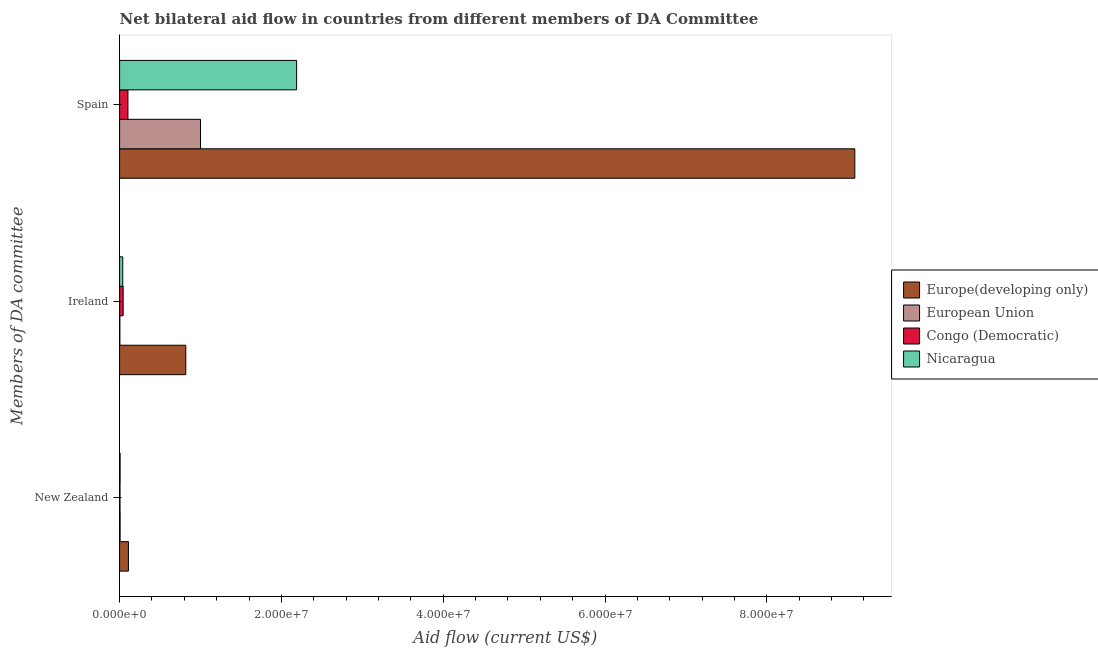How many groups of bars are there?
Your answer should be compact. 3. Are the number of bars per tick equal to the number of legend labels?
Keep it short and to the point. Yes. What is the label of the 2nd group of bars from the top?
Your answer should be compact. Ireland. What is the amount of aid provided by ireland in Nicaragua?
Your answer should be very brief. 3.90e+05. Across all countries, what is the maximum amount of aid provided by new zealand?
Keep it short and to the point. 1.09e+06. Across all countries, what is the minimum amount of aid provided by new zealand?
Your answer should be very brief. 5.00e+04. In which country was the amount of aid provided by spain maximum?
Your answer should be compact. Europe(developing only). In which country was the amount of aid provided by spain minimum?
Keep it short and to the point. Congo (Democratic). What is the total amount of aid provided by new zealand in the graph?
Provide a short and direct response. 1.26e+06. What is the difference between the amount of aid provided by ireland in Europe(developing only) and that in European Union?
Provide a succinct answer. 8.15e+06. What is the difference between the amount of aid provided by spain in Europe(developing only) and the amount of aid provided by ireland in Congo (Democratic)?
Provide a succinct answer. 9.04e+07. What is the average amount of aid provided by spain per country?
Your answer should be compact. 3.09e+07. What is the difference between the amount of aid provided by ireland and amount of aid provided by new zealand in Nicaragua?
Your response must be concise. 3.30e+05. In how many countries, is the amount of aid provided by ireland greater than 24000000 US$?
Provide a short and direct response. 0. Is the amount of aid provided by ireland in Europe(developing only) less than that in European Union?
Provide a succinct answer. No. Is the difference between the amount of aid provided by new zealand in Congo (Democratic) and European Union greater than the difference between the amount of aid provided by spain in Congo (Democratic) and European Union?
Ensure brevity in your answer.  Yes. What is the difference between the highest and the second highest amount of aid provided by spain?
Your answer should be compact. 6.90e+07. What is the difference between the highest and the lowest amount of aid provided by new zealand?
Your answer should be compact. 1.04e+06. In how many countries, is the amount of aid provided by ireland greater than the average amount of aid provided by ireland taken over all countries?
Keep it short and to the point. 1. Is the sum of the amount of aid provided by ireland in Nicaragua and Congo (Democratic) greater than the maximum amount of aid provided by spain across all countries?
Offer a terse response. No. What does the 1st bar from the top in New Zealand represents?
Make the answer very short. Nicaragua. What does the 3rd bar from the bottom in Spain represents?
Offer a very short reply. Congo (Democratic). How many countries are there in the graph?
Your answer should be compact. 4. What is the difference between two consecutive major ticks on the X-axis?
Provide a short and direct response. 2.00e+07. Does the graph contain grids?
Your answer should be compact. No. Where does the legend appear in the graph?
Provide a short and direct response. Center right. How many legend labels are there?
Provide a short and direct response. 4. How are the legend labels stacked?
Give a very brief answer. Vertical. What is the title of the graph?
Provide a short and direct response. Net bilateral aid flow in countries from different members of DA Committee. Does "Paraguay" appear as one of the legend labels in the graph?
Offer a very short reply. No. What is the label or title of the Y-axis?
Your answer should be compact. Members of DA committee. What is the Aid flow (current US$) in Europe(developing only) in New Zealand?
Your answer should be compact. 1.09e+06. What is the Aid flow (current US$) of European Union in New Zealand?
Provide a succinct answer. 6.00e+04. What is the Aid flow (current US$) in Nicaragua in New Zealand?
Offer a very short reply. 6.00e+04. What is the Aid flow (current US$) of Europe(developing only) in Ireland?
Offer a terse response. 8.18e+06. What is the Aid flow (current US$) of European Union in Ireland?
Offer a very short reply. 3.00e+04. What is the Aid flow (current US$) of Europe(developing only) in Spain?
Ensure brevity in your answer.  9.09e+07. What is the Aid flow (current US$) of Congo (Democratic) in Spain?
Your response must be concise. 1.03e+06. What is the Aid flow (current US$) in Nicaragua in Spain?
Your answer should be very brief. 2.19e+07. Across all Members of DA committee, what is the maximum Aid flow (current US$) of Europe(developing only)?
Your answer should be very brief. 9.09e+07. Across all Members of DA committee, what is the maximum Aid flow (current US$) in European Union?
Give a very brief answer. 1.00e+07. Across all Members of DA committee, what is the maximum Aid flow (current US$) in Congo (Democratic)?
Your response must be concise. 1.03e+06. Across all Members of DA committee, what is the maximum Aid flow (current US$) in Nicaragua?
Make the answer very short. 2.19e+07. Across all Members of DA committee, what is the minimum Aid flow (current US$) of Europe(developing only)?
Ensure brevity in your answer.  1.09e+06. Across all Members of DA committee, what is the minimum Aid flow (current US$) of Congo (Democratic)?
Ensure brevity in your answer.  5.00e+04. What is the total Aid flow (current US$) of Europe(developing only) in the graph?
Keep it short and to the point. 1.00e+08. What is the total Aid flow (current US$) of European Union in the graph?
Offer a very short reply. 1.01e+07. What is the total Aid flow (current US$) in Congo (Democratic) in the graph?
Keep it short and to the point. 1.52e+06. What is the total Aid flow (current US$) of Nicaragua in the graph?
Your answer should be very brief. 2.23e+07. What is the difference between the Aid flow (current US$) in Europe(developing only) in New Zealand and that in Ireland?
Your response must be concise. -7.09e+06. What is the difference between the Aid flow (current US$) in European Union in New Zealand and that in Ireland?
Your answer should be very brief. 3.00e+04. What is the difference between the Aid flow (current US$) in Congo (Democratic) in New Zealand and that in Ireland?
Provide a short and direct response. -3.90e+05. What is the difference between the Aid flow (current US$) of Nicaragua in New Zealand and that in Ireland?
Provide a succinct answer. -3.30e+05. What is the difference between the Aid flow (current US$) in Europe(developing only) in New Zealand and that in Spain?
Offer a very short reply. -8.98e+07. What is the difference between the Aid flow (current US$) in European Union in New Zealand and that in Spain?
Provide a succinct answer. -9.94e+06. What is the difference between the Aid flow (current US$) in Congo (Democratic) in New Zealand and that in Spain?
Offer a terse response. -9.80e+05. What is the difference between the Aid flow (current US$) in Nicaragua in New Zealand and that in Spain?
Keep it short and to the point. -2.18e+07. What is the difference between the Aid flow (current US$) of Europe(developing only) in Ireland and that in Spain?
Your answer should be compact. -8.27e+07. What is the difference between the Aid flow (current US$) of European Union in Ireland and that in Spain?
Offer a terse response. -9.97e+06. What is the difference between the Aid flow (current US$) of Congo (Democratic) in Ireland and that in Spain?
Your answer should be compact. -5.90e+05. What is the difference between the Aid flow (current US$) in Nicaragua in Ireland and that in Spain?
Make the answer very short. -2.15e+07. What is the difference between the Aid flow (current US$) in Europe(developing only) in New Zealand and the Aid flow (current US$) in European Union in Ireland?
Offer a very short reply. 1.06e+06. What is the difference between the Aid flow (current US$) in Europe(developing only) in New Zealand and the Aid flow (current US$) in Congo (Democratic) in Ireland?
Your response must be concise. 6.50e+05. What is the difference between the Aid flow (current US$) of Europe(developing only) in New Zealand and the Aid flow (current US$) of Nicaragua in Ireland?
Provide a short and direct response. 7.00e+05. What is the difference between the Aid flow (current US$) of European Union in New Zealand and the Aid flow (current US$) of Congo (Democratic) in Ireland?
Your answer should be very brief. -3.80e+05. What is the difference between the Aid flow (current US$) in European Union in New Zealand and the Aid flow (current US$) in Nicaragua in Ireland?
Your response must be concise. -3.30e+05. What is the difference between the Aid flow (current US$) in Congo (Democratic) in New Zealand and the Aid flow (current US$) in Nicaragua in Ireland?
Offer a very short reply. -3.40e+05. What is the difference between the Aid flow (current US$) in Europe(developing only) in New Zealand and the Aid flow (current US$) in European Union in Spain?
Your answer should be very brief. -8.91e+06. What is the difference between the Aid flow (current US$) in Europe(developing only) in New Zealand and the Aid flow (current US$) in Nicaragua in Spain?
Offer a terse response. -2.08e+07. What is the difference between the Aid flow (current US$) in European Union in New Zealand and the Aid flow (current US$) in Congo (Democratic) in Spain?
Offer a terse response. -9.70e+05. What is the difference between the Aid flow (current US$) in European Union in New Zealand and the Aid flow (current US$) in Nicaragua in Spain?
Ensure brevity in your answer.  -2.18e+07. What is the difference between the Aid flow (current US$) of Congo (Democratic) in New Zealand and the Aid flow (current US$) of Nicaragua in Spain?
Make the answer very short. -2.18e+07. What is the difference between the Aid flow (current US$) in Europe(developing only) in Ireland and the Aid flow (current US$) in European Union in Spain?
Keep it short and to the point. -1.82e+06. What is the difference between the Aid flow (current US$) of Europe(developing only) in Ireland and the Aid flow (current US$) of Congo (Democratic) in Spain?
Offer a very short reply. 7.15e+06. What is the difference between the Aid flow (current US$) in Europe(developing only) in Ireland and the Aid flow (current US$) in Nicaragua in Spain?
Ensure brevity in your answer.  -1.37e+07. What is the difference between the Aid flow (current US$) in European Union in Ireland and the Aid flow (current US$) in Congo (Democratic) in Spain?
Offer a terse response. -1.00e+06. What is the difference between the Aid flow (current US$) of European Union in Ireland and the Aid flow (current US$) of Nicaragua in Spain?
Give a very brief answer. -2.18e+07. What is the difference between the Aid flow (current US$) in Congo (Democratic) in Ireland and the Aid flow (current US$) in Nicaragua in Spain?
Give a very brief answer. -2.14e+07. What is the average Aid flow (current US$) in Europe(developing only) per Members of DA committee?
Your answer should be very brief. 3.34e+07. What is the average Aid flow (current US$) of European Union per Members of DA committee?
Your response must be concise. 3.36e+06. What is the average Aid flow (current US$) in Congo (Democratic) per Members of DA committee?
Offer a terse response. 5.07e+05. What is the average Aid flow (current US$) in Nicaragua per Members of DA committee?
Keep it short and to the point. 7.44e+06. What is the difference between the Aid flow (current US$) of Europe(developing only) and Aid flow (current US$) of European Union in New Zealand?
Provide a succinct answer. 1.03e+06. What is the difference between the Aid flow (current US$) of Europe(developing only) and Aid flow (current US$) of Congo (Democratic) in New Zealand?
Give a very brief answer. 1.04e+06. What is the difference between the Aid flow (current US$) in Europe(developing only) and Aid flow (current US$) in Nicaragua in New Zealand?
Provide a short and direct response. 1.03e+06. What is the difference between the Aid flow (current US$) of European Union and Aid flow (current US$) of Congo (Democratic) in New Zealand?
Your answer should be very brief. 10000. What is the difference between the Aid flow (current US$) of Congo (Democratic) and Aid flow (current US$) of Nicaragua in New Zealand?
Your answer should be very brief. -10000. What is the difference between the Aid flow (current US$) of Europe(developing only) and Aid flow (current US$) of European Union in Ireland?
Make the answer very short. 8.15e+06. What is the difference between the Aid flow (current US$) of Europe(developing only) and Aid flow (current US$) of Congo (Democratic) in Ireland?
Offer a very short reply. 7.74e+06. What is the difference between the Aid flow (current US$) in Europe(developing only) and Aid flow (current US$) in Nicaragua in Ireland?
Make the answer very short. 7.79e+06. What is the difference between the Aid flow (current US$) in European Union and Aid flow (current US$) in Congo (Democratic) in Ireland?
Your answer should be very brief. -4.10e+05. What is the difference between the Aid flow (current US$) of European Union and Aid flow (current US$) of Nicaragua in Ireland?
Your answer should be compact. -3.60e+05. What is the difference between the Aid flow (current US$) in Congo (Democratic) and Aid flow (current US$) in Nicaragua in Ireland?
Offer a terse response. 5.00e+04. What is the difference between the Aid flow (current US$) of Europe(developing only) and Aid flow (current US$) of European Union in Spain?
Offer a very short reply. 8.09e+07. What is the difference between the Aid flow (current US$) of Europe(developing only) and Aid flow (current US$) of Congo (Democratic) in Spain?
Offer a very short reply. 8.98e+07. What is the difference between the Aid flow (current US$) in Europe(developing only) and Aid flow (current US$) in Nicaragua in Spain?
Your answer should be very brief. 6.90e+07. What is the difference between the Aid flow (current US$) of European Union and Aid flow (current US$) of Congo (Democratic) in Spain?
Provide a succinct answer. 8.97e+06. What is the difference between the Aid flow (current US$) in European Union and Aid flow (current US$) in Nicaragua in Spain?
Offer a terse response. -1.19e+07. What is the difference between the Aid flow (current US$) in Congo (Democratic) and Aid flow (current US$) in Nicaragua in Spain?
Make the answer very short. -2.08e+07. What is the ratio of the Aid flow (current US$) of Europe(developing only) in New Zealand to that in Ireland?
Your answer should be very brief. 0.13. What is the ratio of the Aid flow (current US$) of Congo (Democratic) in New Zealand to that in Ireland?
Offer a very short reply. 0.11. What is the ratio of the Aid flow (current US$) of Nicaragua in New Zealand to that in Ireland?
Your response must be concise. 0.15. What is the ratio of the Aid flow (current US$) of Europe(developing only) in New Zealand to that in Spain?
Make the answer very short. 0.01. What is the ratio of the Aid flow (current US$) in European Union in New Zealand to that in Spain?
Keep it short and to the point. 0.01. What is the ratio of the Aid flow (current US$) of Congo (Democratic) in New Zealand to that in Spain?
Provide a short and direct response. 0.05. What is the ratio of the Aid flow (current US$) of Nicaragua in New Zealand to that in Spain?
Give a very brief answer. 0. What is the ratio of the Aid flow (current US$) of Europe(developing only) in Ireland to that in Spain?
Ensure brevity in your answer.  0.09. What is the ratio of the Aid flow (current US$) of European Union in Ireland to that in Spain?
Your answer should be compact. 0. What is the ratio of the Aid flow (current US$) in Congo (Democratic) in Ireland to that in Spain?
Provide a succinct answer. 0.43. What is the ratio of the Aid flow (current US$) in Nicaragua in Ireland to that in Spain?
Your response must be concise. 0.02. What is the difference between the highest and the second highest Aid flow (current US$) in Europe(developing only)?
Ensure brevity in your answer.  8.27e+07. What is the difference between the highest and the second highest Aid flow (current US$) of European Union?
Give a very brief answer. 9.94e+06. What is the difference between the highest and the second highest Aid flow (current US$) in Congo (Democratic)?
Keep it short and to the point. 5.90e+05. What is the difference between the highest and the second highest Aid flow (current US$) of Nicaragua?
Your response must be concise. 2.15e+07. What is the difference between the highest and the lowest Aid flow (current US$) in Europe(developing only)?
Provide a succinct answer. 8.98e+07. What is the difference between the highest and the lowest Aid flow (current US$) in European Union?
Offer a very short reply. 9.97e+06. What is the difference between the highest and the lowest Aid flow (current US$) of Congo (Democratic)?
Your response must be concise. 9.80e+05. What is the difference between the highest and the lowest Aid flow (current US$) of Nicaragua?
Give a very brief answer. 2.18e+07. 